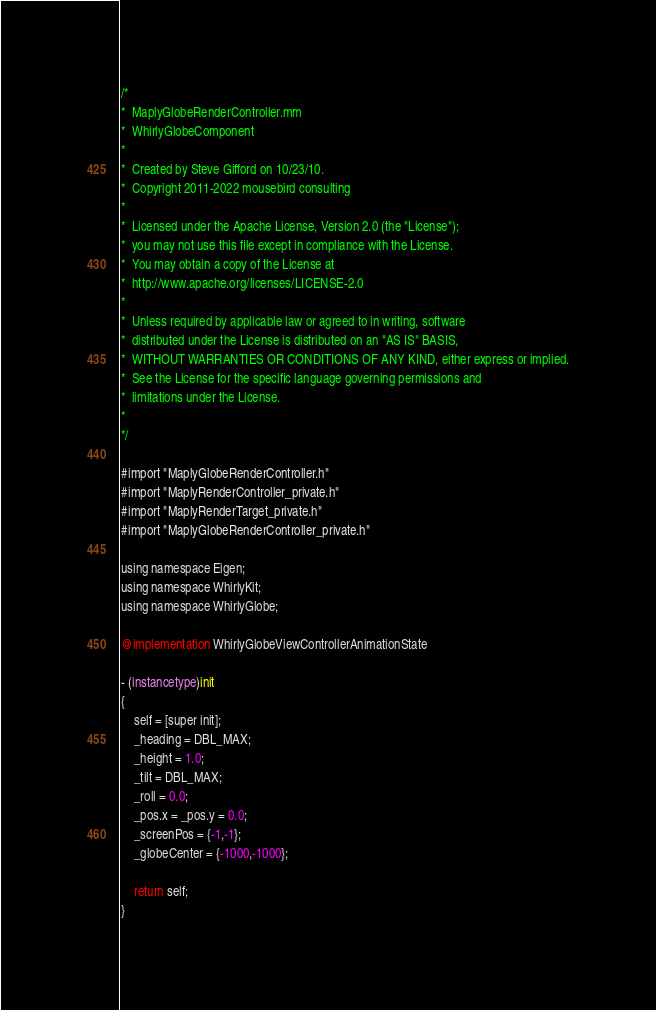Convert code to text. <code><loc_0><loc_0><loc_500><loc_500><_ObjectiveC_>/*
*  MaplyGlobeRenderController.mm
*  WhirlyGlobeComponent
*
*  Created by Steve Gifford on 10/23/10.
*  Copyright 2011-2022 mousebird consulting
*
*  Licensed under the Apache License, Version 2.0 (the "License");
*  you may not use this file except in compliance with the License.
*  You may obtain a copy of the License at
*  http://www.apache.org/licenses/LICENSE-2.0
*
*  Unless required by applicable law or agreed to in writing, software
*  distributed under the License is distributed on an "AS IS" BASIS,
*  WITHOUT WARRANTIES OR CONDITIONS OF ANY KIND, either express or implied.
*  See the License for the specific language governing permissions and
*  limitations under the License.
*
*/

#import "MaplyGlobeRenderController.h"
#import "MaplyRenderController_private.h"
#import "MaplyRenderTarget_private.h"
#import "MaplyGlobeRenderController_private.h"

using namespace Eigen;
using namespace WhirlyKit;
using namespace WhirlyGlobe;

@implementation WhirlyGlobeViewControllerAnimationState

- (instancetype)init
{
    self = [super init];
    _heading = DBL_MAX;
    _height = 1.0;
    _tilt = DBL_MAX;
    _roll = 0.0;
    _pos.x = _pos.y = 0.0;
    _screenPos = {-1,-1};
    _globeCenter = {-1000,-1000};
    
    return self;
}
</code> 